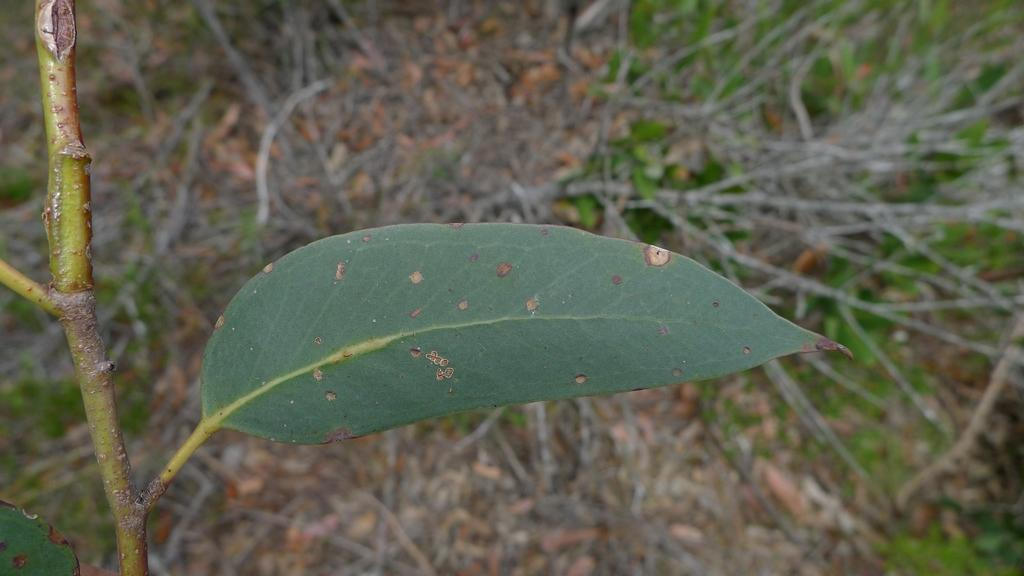What is the main object in the image? There is a stem with a leaf in the image. What can be seen at the bottom of the image? There are wooden sticks and dry leaves present at the bottom of the image. Can you describe the condition of the leaf? The leaf has spots on it. How many lifts are available in the image? There are no lifts present in the image. What type of pear is visible in the image? There is no pear present in the image. 